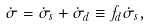<formula> <loc_0><loc_0><loc_500><loc_500>\dot { \sigma } = \dot { \sigma } _ { s } + \dot { \sigma } _ { d } \equiv f _ { d } \dot { \sigma } _ { s } ,</formula> 